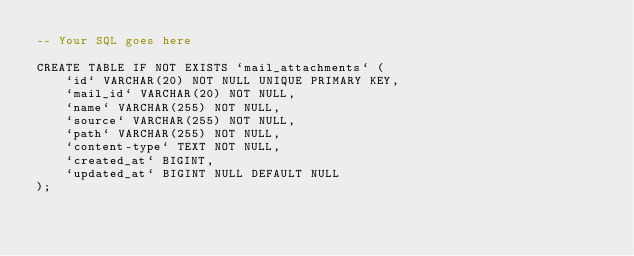<code> <loc_0><loc_0><loc_500><loc_500><_SQL_>-- Your SQL goes here

CREATE TABLE IF NOT EXISTS `mail_attachments` (
    `id` VARCHAR(20) NOT NULL UNIQUE PRIMARY KEY,
    `mail_id` VARCHAR(20) NOT NULL,
    `name` VARCHAR(255) NOT NULL,
    `source` VARCHAR(255) NOT NULL,
    `path` VARCHAR(255) NOT NULL,
    `content-type` TEXT NOT NULL,
    `created_at` BIGINT,
    `updated_at` BIGINT NULL DEFAULT NULL
);
</code> 